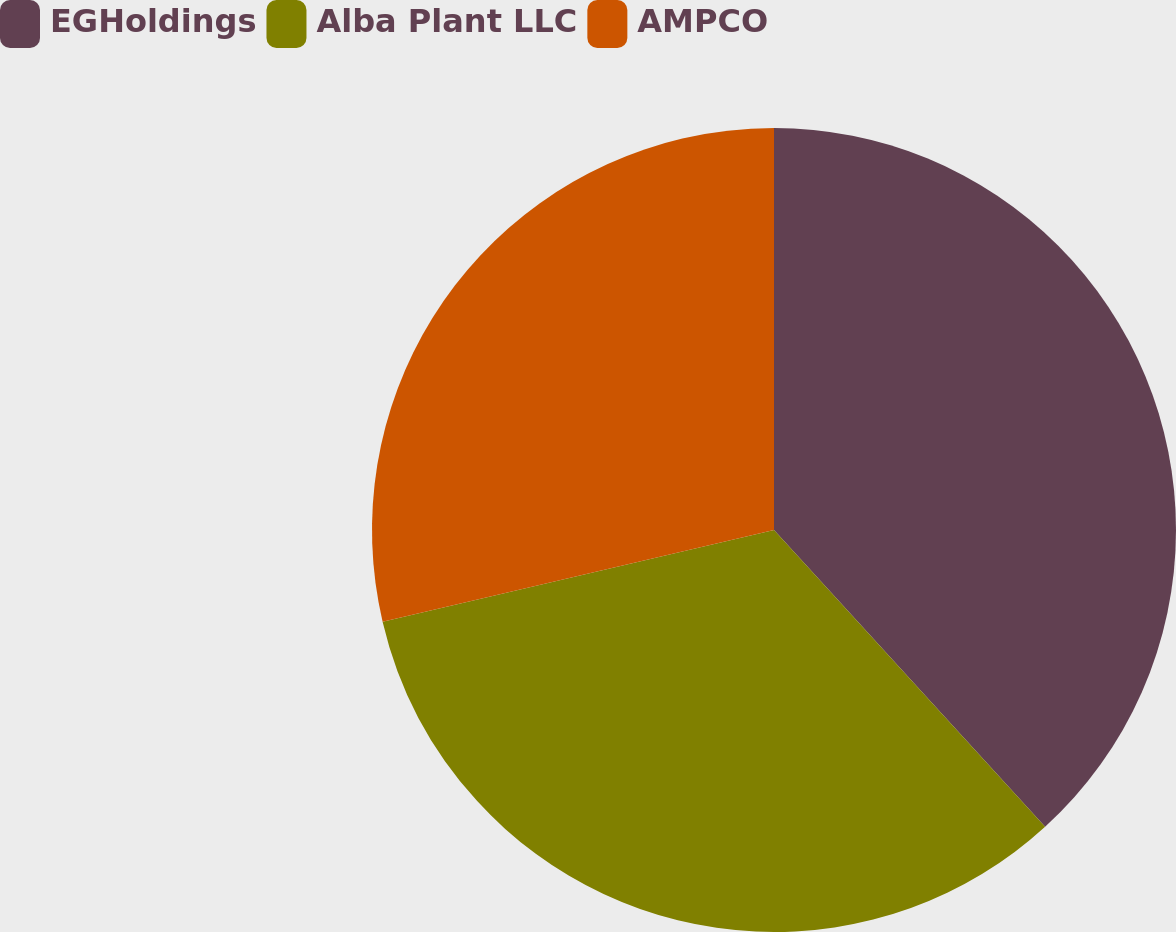Convert chart to OTSL. <chart><loc_0><loc_0><loc_500><loc_500><pie_chart><fcel>EGHoldings<fcel>Alba Plant LLC<fcel>AMPCO<nl><fcel>38.22%<fcel>33.12%<fcel>28.66%<nl></chart> 